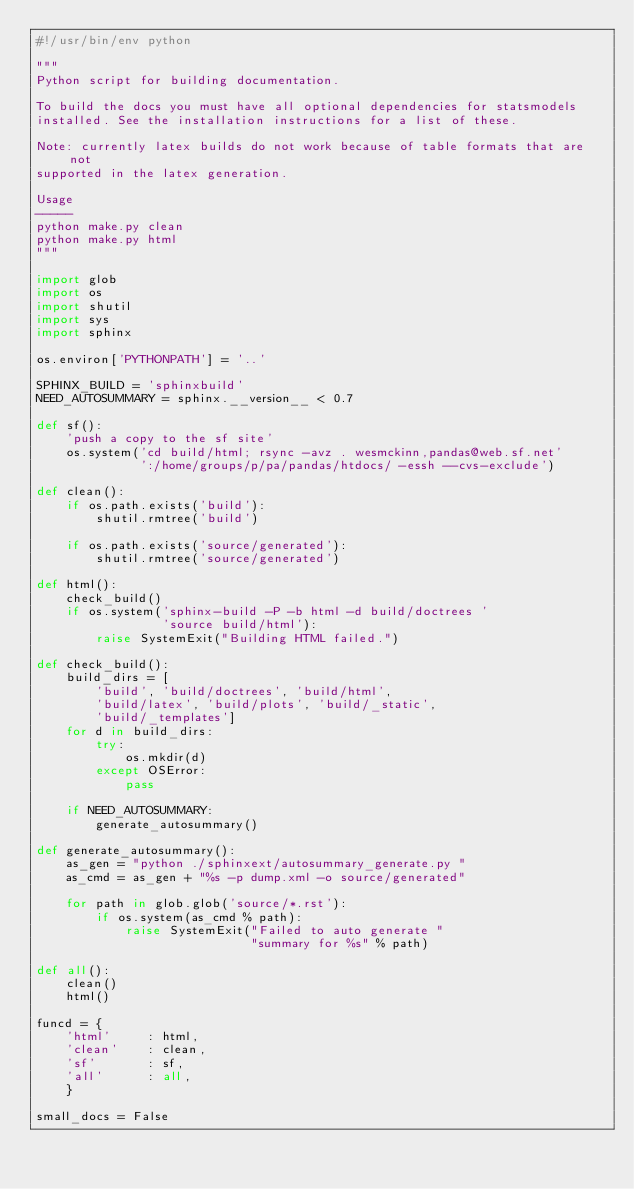Convert code to text. <code><loc_0><loc_0><loc_500><loc_500><_Python_>#!/usr/bin/env python

"""
Python script for building documentation.

To build the docs you must have all optional dependencies for statsmodels
installed. See the installation instructions for a list of these.

Note: currently latex builds do not work because of table formats that are not
supported in the latex generation.

Usage
-----
python make.py clean
python make.py html
"""

import glob
import os
import shutil
import sys
import sphinx

os.environ['PYTHONPATH'] = '..'

SPHINX_BUILD = 'sphinxbuild'
NEED_AUTOSUMMARY = sphinx.__version__ < 0.7

def sf():
    'push a copy to the sf site'
    os.system('cd build/html; rsync -avz . wesmckinn,pandas@web.sf.net'
              ':/home/groups/p/pa/pandas/htdocs/ -essh --cvs-exclude')

def clean():
    if os.path.exists('build'):
        shutil.rmtree('build')

    if os.path.exists('source/generated'):
        shutil.rmtree('source/generated')

def html():
    check_build()
    if os.system('sphinx-build -P -b html -d build/doctrees '
                 'source build/html'):
        raise SystemExit("Building HTML failed.")

def check_build():
    build_dirs = [
        'build', 'build/doctrees', 'build/html',
        'build/latex', 'build/plots', 'build/_static',
        'build/_templates']
    for d in build_dirs:
        try:
            os.mkdir(d)
        except OSError:
            pass

    if NEED_AUTOSUMMARY:
        generate_autosummary()

def generate_autosummary():
    as_gen = "python ./sphinxext/autosummary_generate.py "
    as_cmd = as_gen + "%s -p dump.xml -o source/generated"

    for path in glob.glob('source/*.rst'):
        if os.system(as_cmd % path):
            raise SystemExit("Failed to auto generate "
                             "summary for %s" % path)

def all():
    clean()
    html()

funcd = {
    'html'     : html,
    'clean'    : clean,
    'sf'       : sf,
    'all'      : all,
    }

small_docs = False
</code> 